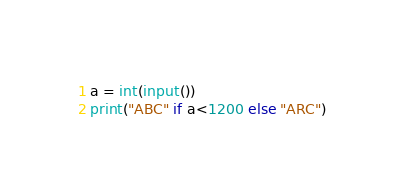<code> <loc_0><loc_0><loc_500><loc_500><_Python_>a = int(input())
print("ABC" if a<1200 else "ARC")</code> 